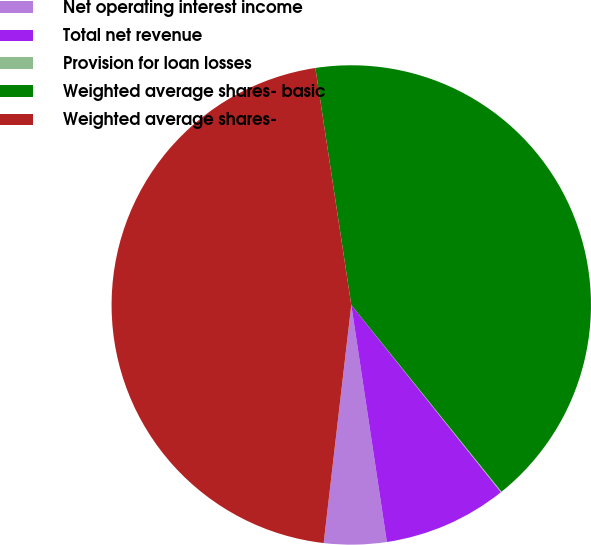Convert chart to OTSL. <chart><loc_0><loc_0><loc_500><loc_500><pie_chart><fcel>Net operating interest income<fcel>Total net revenue<fcel>Provision for loan losses<fcel>Weighted average shares- basic<fcel>Weighted average shares-<nl><fcel>4.21%<fcel>8.36%<fcel>0.05%<fcel>41.61%<fcel>45.77%<nl></chart> 